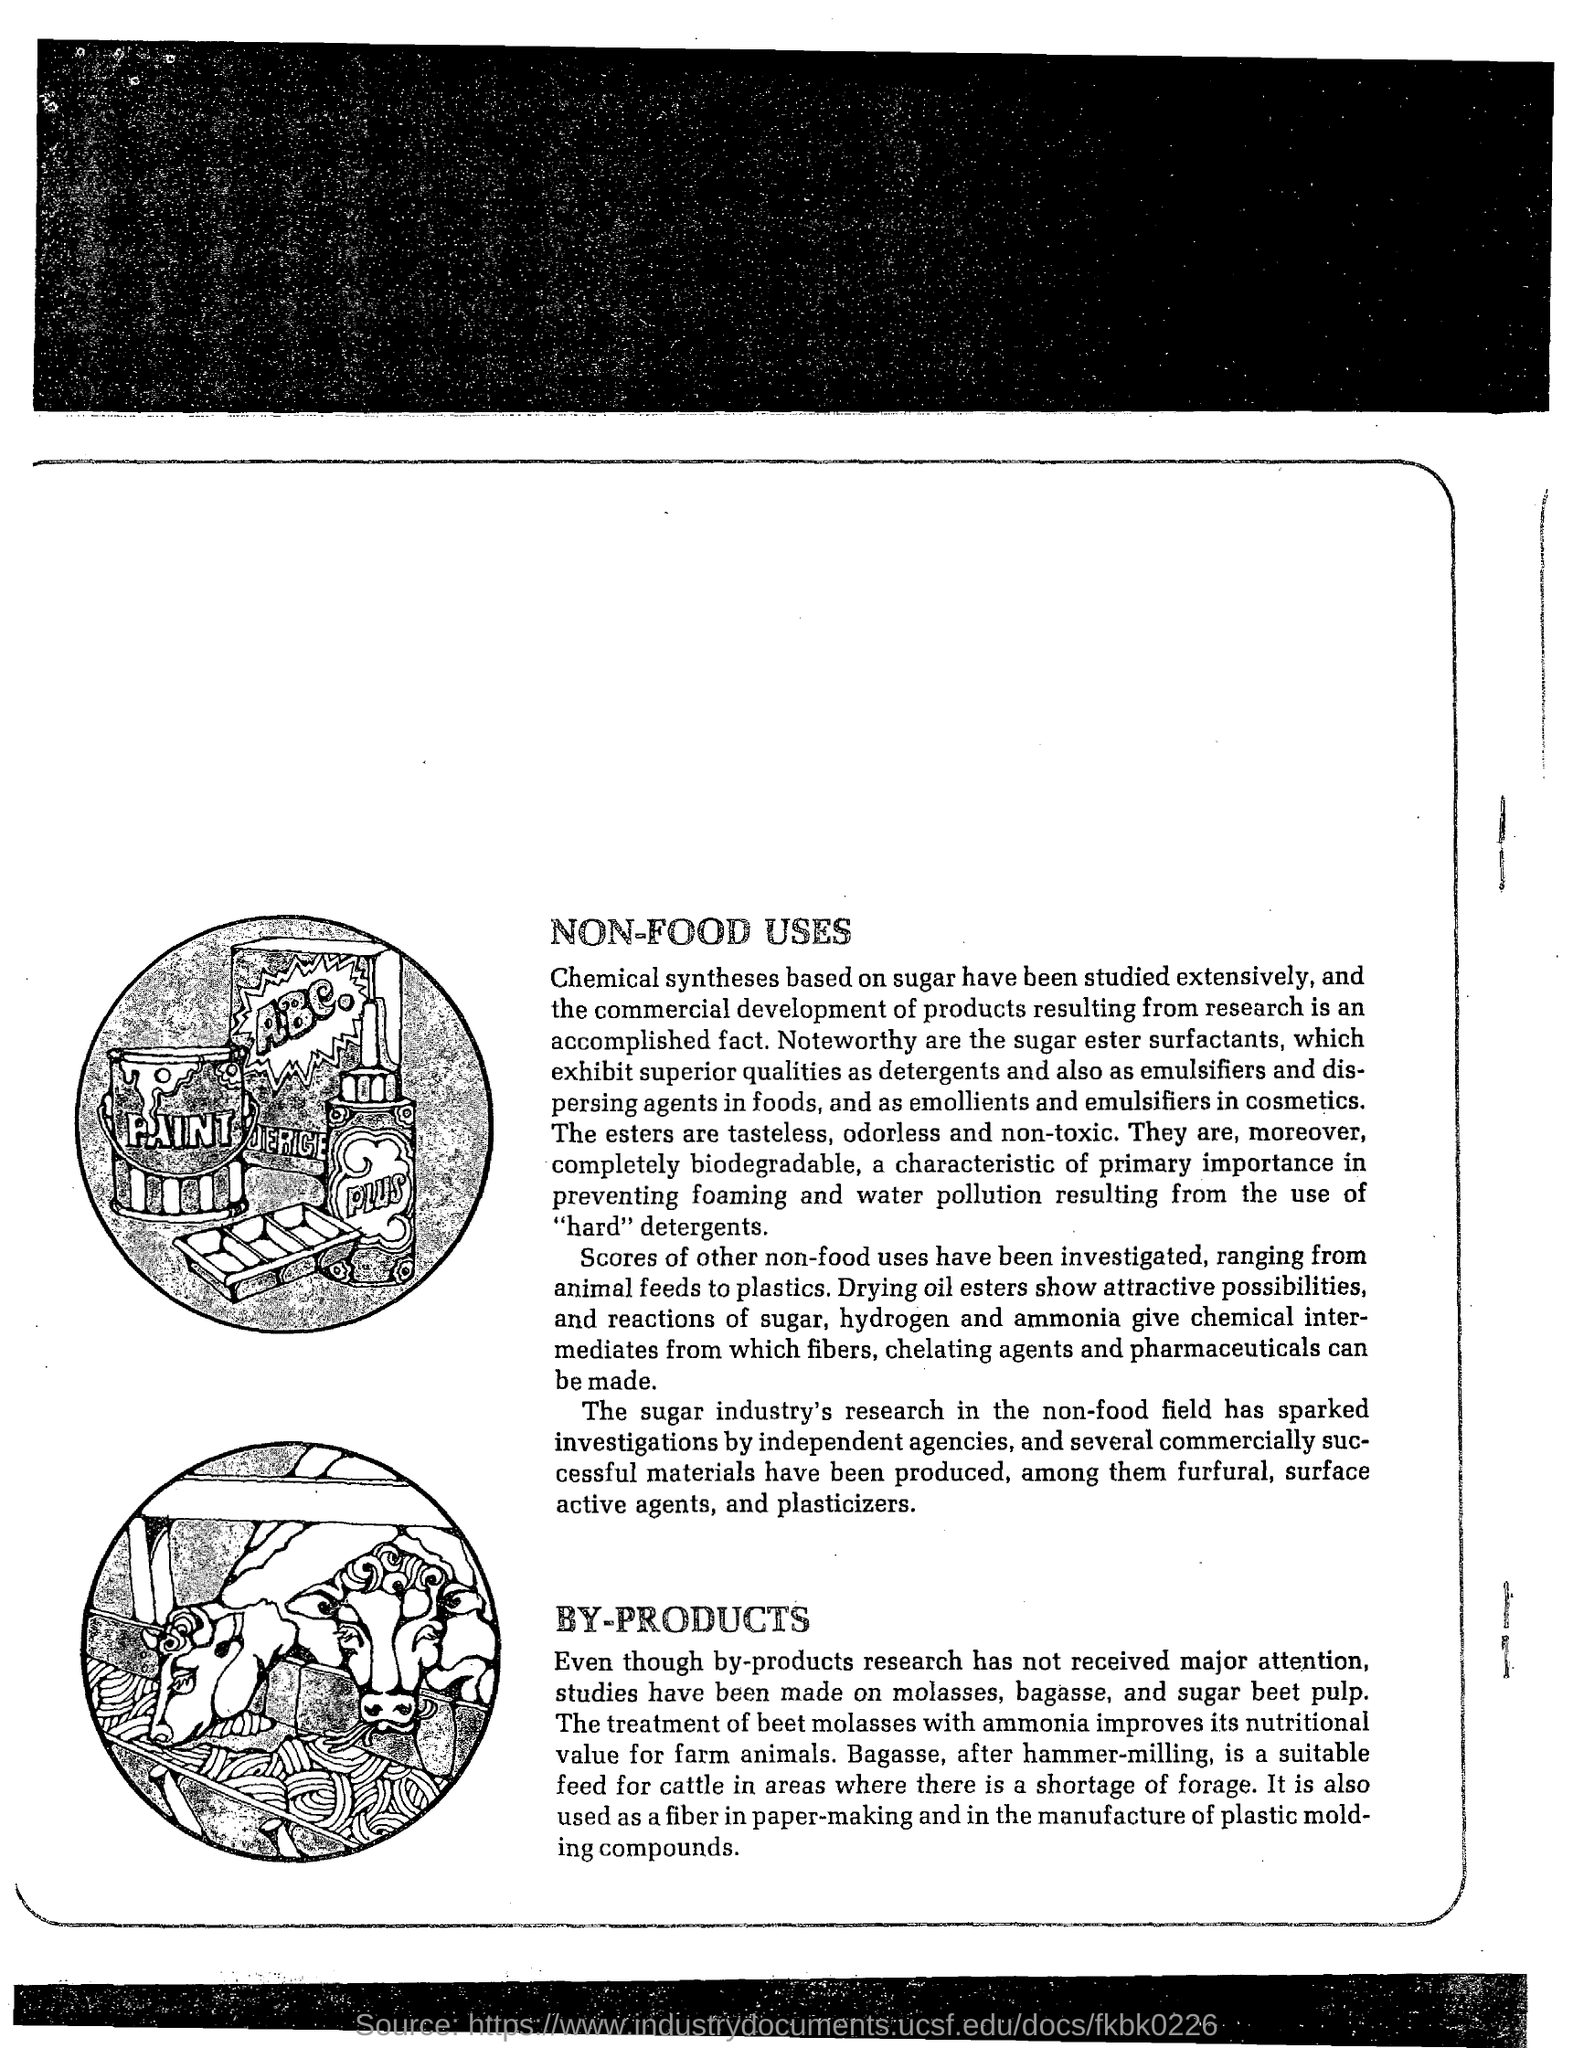List a handful of essential elements in this visual. After hammer-milling, a suitable feed for cattle is bagasse, which is a byproduct of sugarcane processing. Beet molasses can be improved in its nutritional value for farm animals through the treatment with ammonia, which results in a more beneficial form of the substance. Sugar ester surfactants can be used as effective detergents and emulsifiers in various applications. 